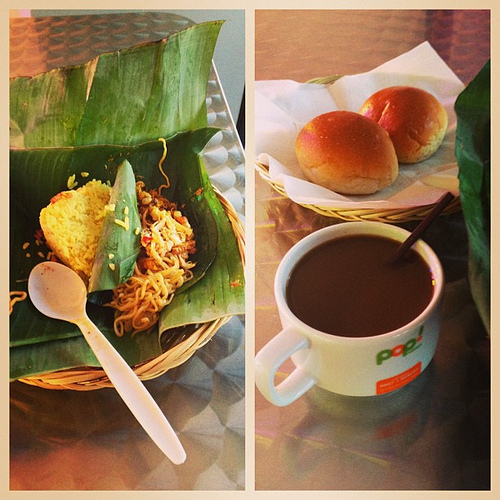What does the choice of crockery and cutlery suggest about the dining experience? The use of a woven basket, a plastic spoon, and a sturdy mug implies a dining experience that values practicality and authenticity over formality. It suggests a casual, possibly outdoor or picnic-like setting, where the enjoyment of the meal takes precedence over the tableware's aesthetics. 